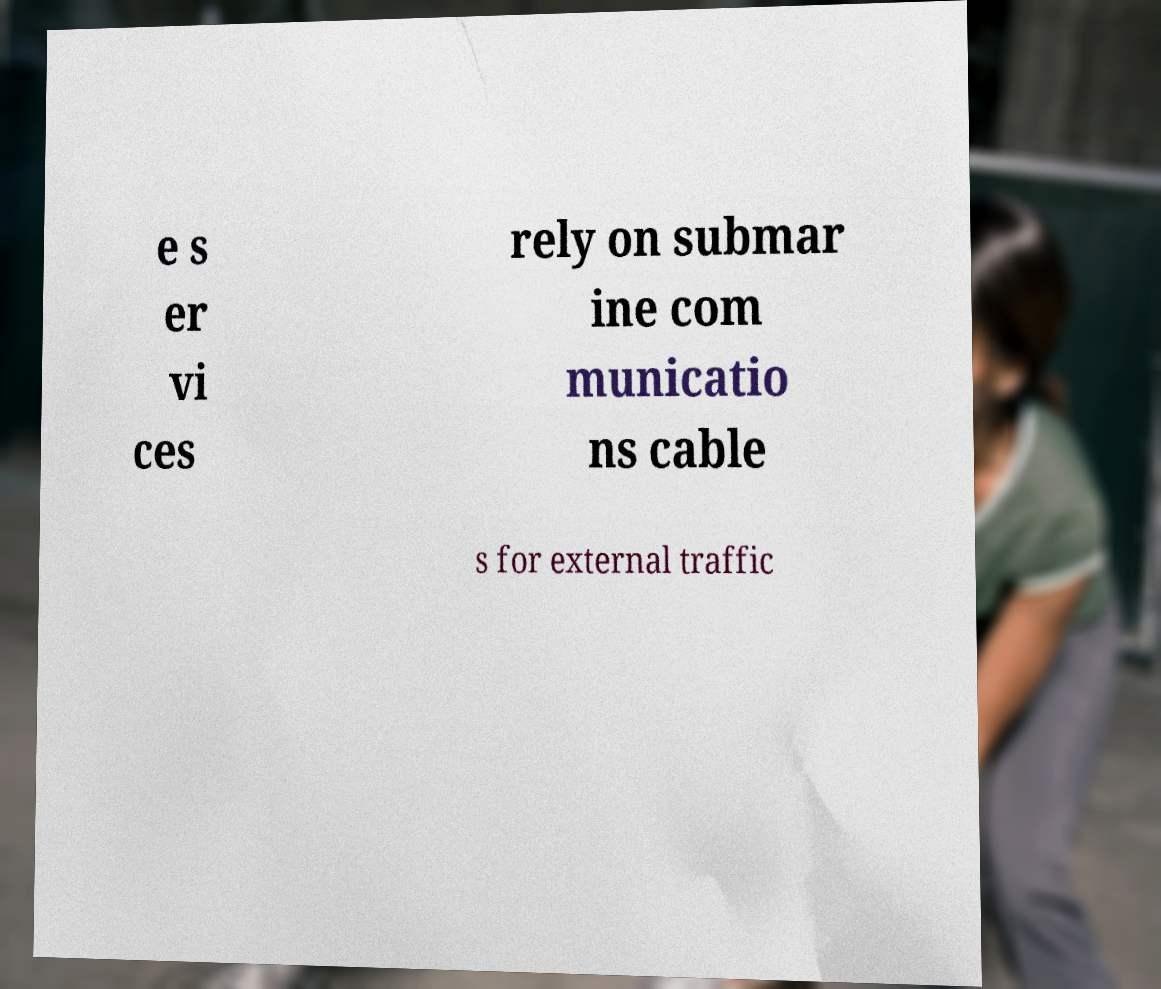For documentation purposes, I need the text within this image transcribed. Could you provide that? e s er vi ces rely on submar ine com municatio ns cable s for external traffic 